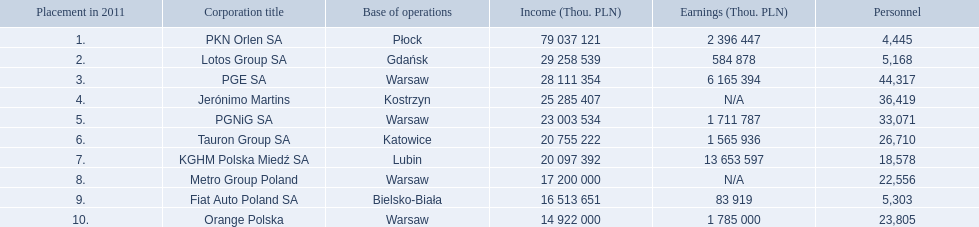What is the number of employees that work for pkn orlen sa in poland? 4,445. What number of employees work for lotos group sa? 5,168. How many people work for pgnig sa? 33,071. 